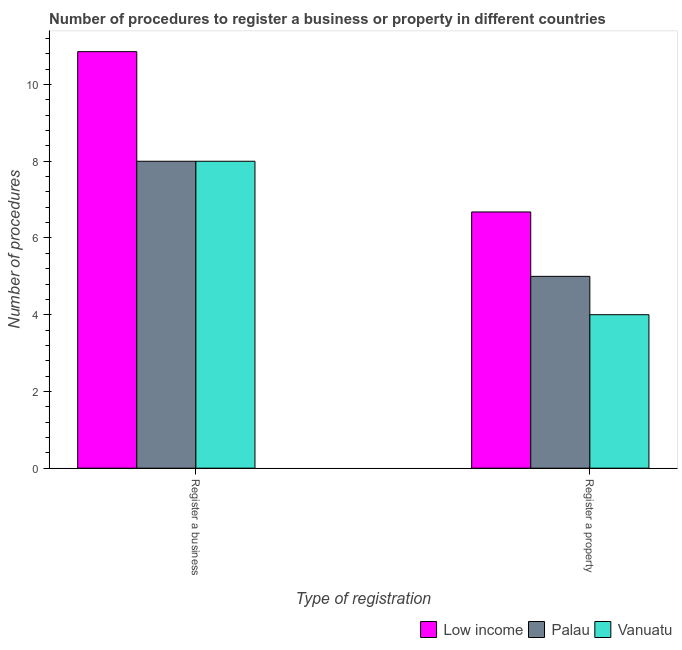Are the number of bars per tick equal to the number of legend labels?
Provide a succinct answer. Yes. How many bars are there on the 1st tick from the left?
Keep it short and to the point. 3. How many bars are there on the 2nd tick from the right?
Your answer should be very brief. 3. What is the label of the 2nd group of bars from the left?
Keep it short and to the point. Register a property. Across all countries, what is the maximum number of procedures to register a property?
Provide a succinct answer. 6.68. Across all countries, what is the minimum number of procedures to register a property?
Ensure brevity in your answer.  4. In which country was the number of procedures to register a business maximum?
Give a very brief answer. Low income. In which country was the number of procedures to register a business minimum?
Offer a very short reply. Palau. What is the total number of procedures to register a business in the graph?
Your response must be concise. 26.86. What is the difference between the number of procedures to register a business in Low income and the number of procedures to register a property in Vanuatu?
Keep it short and to the point. 6.86. What is the average number of procedures to register a business per country?
Your answer should be very brief. 8.95. What is the difference between the number of procedures to register a property and number of procedures to register a business in Vanuatu?
Your response must be concise. -4. In how many countries, is the number of procedures to register a property greater than 10.4 ?
Your answer should be compact. 0. What does the 1st bar from the left in Register a property represents?
Offer a very short reply. Low income. What does the 2nd bar from the right in Register a property represents?
Provide a short and direct response. Palau. How many bars are there?
Offer a terse response. 6. Are all the bars in the graph horizontal?
Your response must be concise. No. How many countries are there in the graph?
Keep it short and to the point. 3. What is the difference between two consecutive major ticks on the Y-axis?
Make the answer very short. 2. Does the graph contain any zero values?
Ensure brevity in your answer.  No. Where does the legend appear in the graph?
Your answer should be very brief. Bottom right. What is the title of the graph?
Your response must be concise. Number of procedures to register a business or property in different countries. What is the label or title of the X-axis?
Keep it short and to the point. Type of registration. What is the label or title of the Y-axis?
Your answer should be compact. Number of procedures. What is the Number of procedures of Low income in Register a business?
Provide a short and direct response. 10.86. What is the Number of procedures of Palau in Register a business?
Offer a very short reply. 8. What is the Number of procedures of Vanuatu in Register a business?
Offer a very short reply. 8. What is the Number of procedures in Low income in Register a property?
Offer a terse response. 6.68. What is the Number of procedures in Palau in Register a property?
Keep it short and to the point. 5. What is the Number of procedures of Vanuatu in Register a property?
Offer a very short reply. 4. Across all Type of registration, what is the maximum Number of procedures in Low income?
Your response must be concise. 10.86. Across all Type of registration, what is the maximum Number of procedures in Palau?
Offer a terse response. 8. Across all Type of registration, what is the maximum Number of procedures in Vanuatu?
Keep it short and to the point. 8. Across all Type of registration, what is the minimum Number of procedures in Low income?
Ensure brevity in your answer.  6.68. What is the total Number of procedures of Low income in the graph?
Ensure brevity in your answer.  17.54. What is the total Number of procedures in Palau in the graph?
Your answer should be very brief. 13. What is the difference between the Number of procedures of Low income in Register a business and that in Register a property?
Provide a short and direct response. 4.18. What is the difference between the Number of procedures in Palau in Register a business and that in Register a property?
Provide a succinct answer. 3. What is the difference between the Number of procedures in Vanuatu in Register a business and that in Register a property?
Offer a very short reply. 4. What is the difference between the Number of procedures in Low income in Register a business and the Number of procedures in Palau in Register a property?
Ensure brevity in your answer.  5.86. What is the difference between the Number of procedures of Low income in Register a business and the Number of procedures of Vanuatu in Register a property?
Your answer should be compact. 6.86. What is the difference between the Number of procedures in Palau in Register a business and the Number of procedures in Vanuatu in Register a property?
Offer a very short reply. 4. What is the average Number of procedures in Low income per Type of registration?
Your answer should be compact. 8.77. What is the average Number of procedures in Vanuatu per Type of registration?
Ensure brevity in your answer.  6. What is the difference between the Number of procedures of Low income and Number of procedures of Palau in Register a business?
Offer a terse response. 2.86. What is the difference between the Number of procedures in Low income and Number of procedures in Vanuatu in Register a business?
Keep it short and to the point. 2.86. What is the difference between the Number of procedures of Palau and Number of procedures of Vanuatu in Register a business?
Provide a short and direct response. 0. What is the difference between the Number of procedures of Low income and Number of procedures of Palau in Register a property?
Provide a succinct answer. 1.68. What is the difference between the Number of procedures in Low income and Number of procedures in Vanuatu in Register a property?
Give a very brief answer. 2.68. What is the difference between the Number of procedures of Palau and Number of procedures of Vanuatu in Register a property?
Keep it short and to the point. 1. What is the ratio of the Number of procedures in Low income in Register a business to that in Register a property?
Keep it short and to the point. 1.63. What is the ratio of the Number of procedures of Palau in Register a business to that in Register a property?
Give a very brief answer. 1.6. What is the difference between the highest and the second highest Number of procedures of Low income?
Give a very brief answer. 4.18. What is the difference between the highest and the second highest Number of procedures of Vanuatu?
Offer a terse response. 4. What is the difference between the highest and the lowest Number of procedures in Low income?
Ensure brevity in your answer.  4.18. What is the difference between the highest and the lowest Number of procedures in Vanuatu?
Provide a succinct answer. 4. 